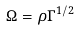<formula> <loc_0><loc_0><loc_500><loc_500>\Omega = \rho \Gamma ^ { 1 / 2 }</formula> 